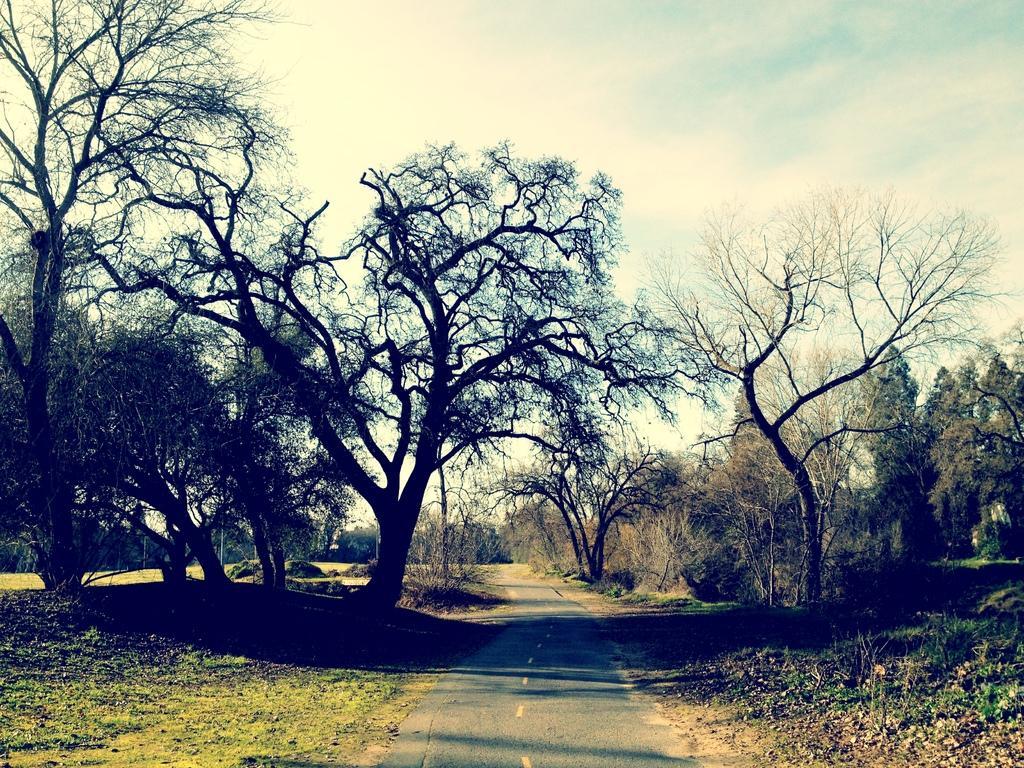Describe this image in one or two sentences. In this image there are trees and there is grass on the ground and the sky is cloudy. 